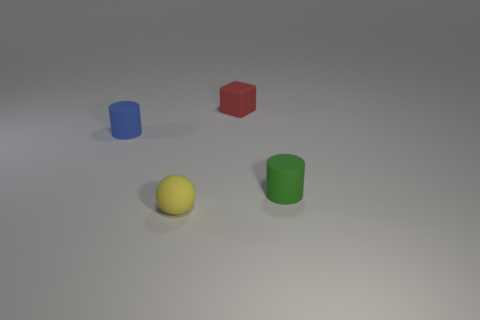Does the red object have the same size as the thing that is in front of the small green thing? Upon observation, the red cube appears to be larger in size compared to the yellow sphere that is positioned in front of the green cylinder, which is smaller. Therefore, they do not have the same size. 